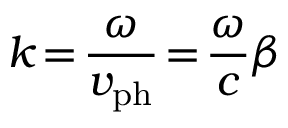Convert formula to latex. <formula><loc_0><loc_0><loc_500><loc_500>k \, = \, \frac { \omega } { v _ { p h } } \, = \, \frac { \omega } { c } \beta</formula> 